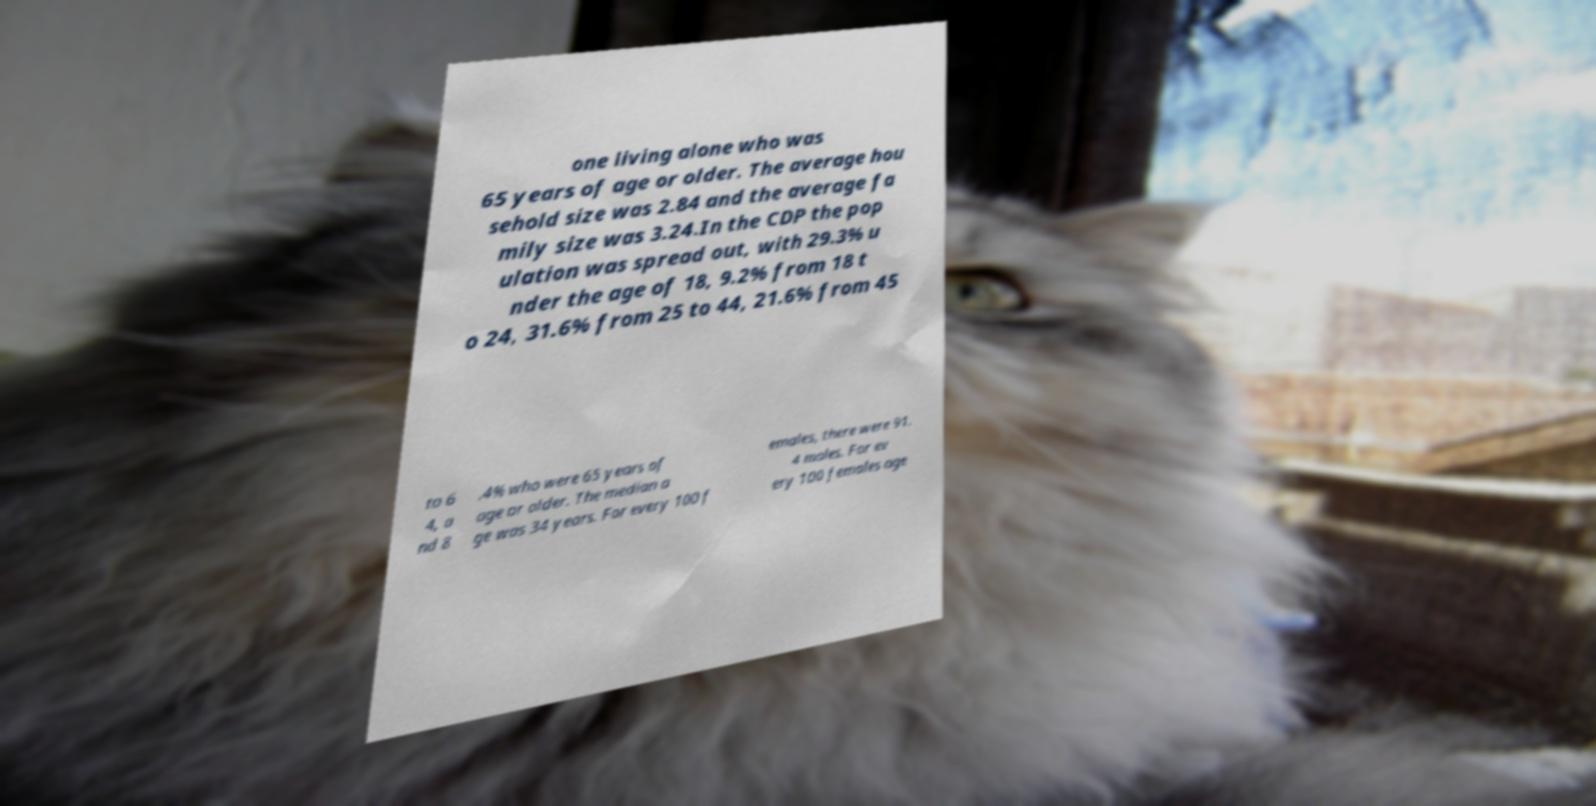Could you assist in decoding the text presented in this image and type it out clearly? one living alone who was 65 years of age or older. The average hou sehold size was 2.84 and the average fa mily size was 3.24.In the CDP the pop ulation was spread out, with 29.3% u nder the age of 18, 9.2% from 18 t o 24, 31.6% from 25 to 44, 21.6% from 45 to 6 4, a nd 8 .4% who were 65 years of age or older. The median a ge was 34 years. For every 100 f emales, there were 91. 4 males. For ev ery 100 females age 